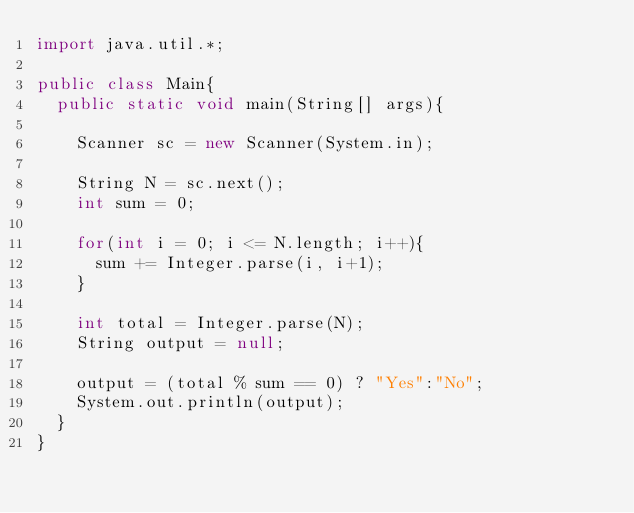Convert code to text. <code><loc_0><loc_0><loc_500><loc_500><_Java_>import java.util.*;
 
public class Main{
  public static void main(String[] args){
    
    Scanner sc = new Scanner(System.in);
    
    String N = sc.next();
    int sum = 0;
 
    for(int i = 0; i <= N.length; i++){
      sum += Integer.parse(i, i+1);
    }
    
    int total = Integer.parse(N);
    String output = null;
    
    output = (total % sum == 0) ? "Yes":"No";
    System.out.println(output);
  }
}</code> 